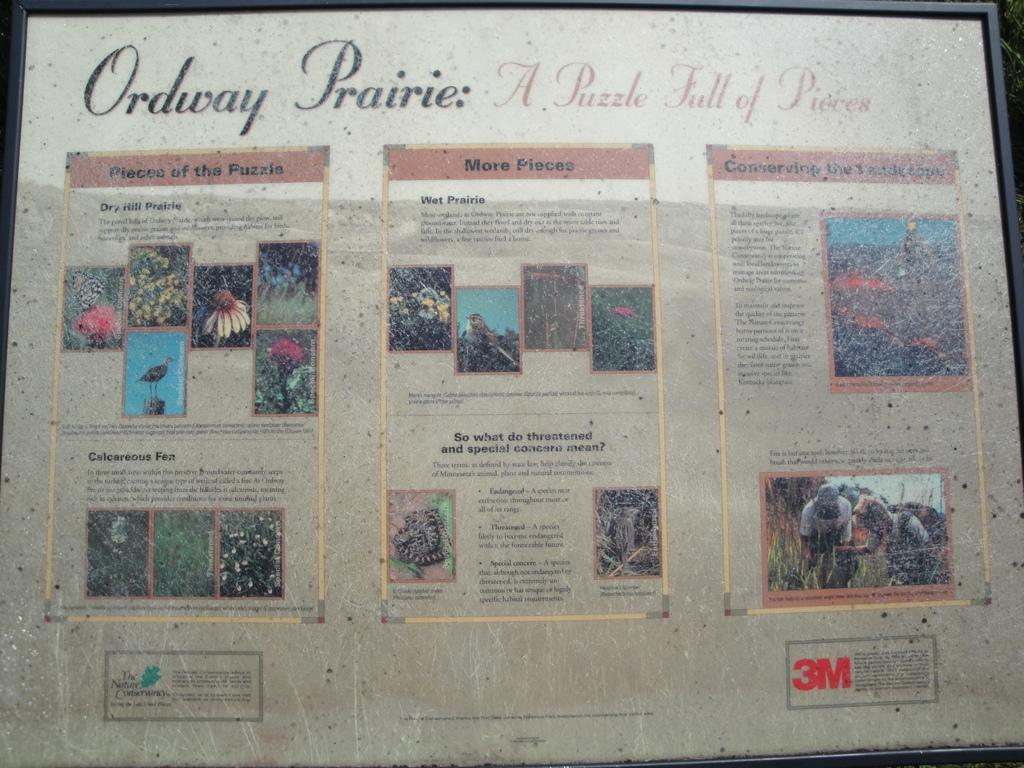<image>
Describe the image concisely. A large article in a frame explains a puzzle. 